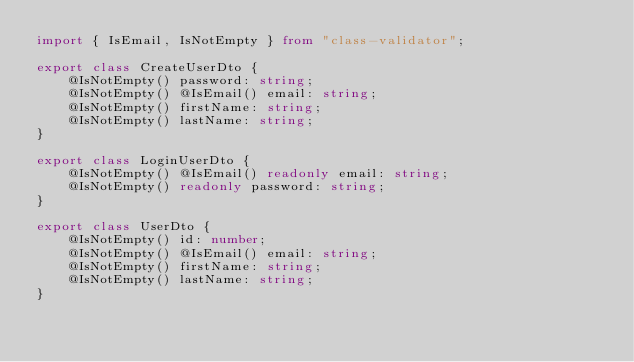<code> <loc_0><loc_0><loc_500><loc_500><_TypeScript_>import { IsEmail, IsNotEmpty } from "class-validator";

export class CreateUserDto {
    @IsNotEmpty() password: string;
    @IsNotEmpty() @IsEmail() email: string;
    @IsNotEmpty() firstName: string;
    @IsNotEmpty() lastName: string;
}

export class LoginUserDto {
    @IsNotEmpty() @IsEmail() readonly email: string;
    @IsNotEmpty() readonly password: string;
}

export class UserDto {
    @IsNotEmpty() id: number;
    @IsNotEmpty() @IsEmail() email: string;
    @IsNotEmpty() firstName: string;
    @IsNotEmpty() lastName: string;
}</code> 